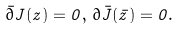<formula> <loc_0><loc_0><loc_500><loc_500>\bar { \partial } { J ( z ) } = 0 , \, { \partial } { \bar { J } ( \bar { z } ) } = 0 .</formula> 